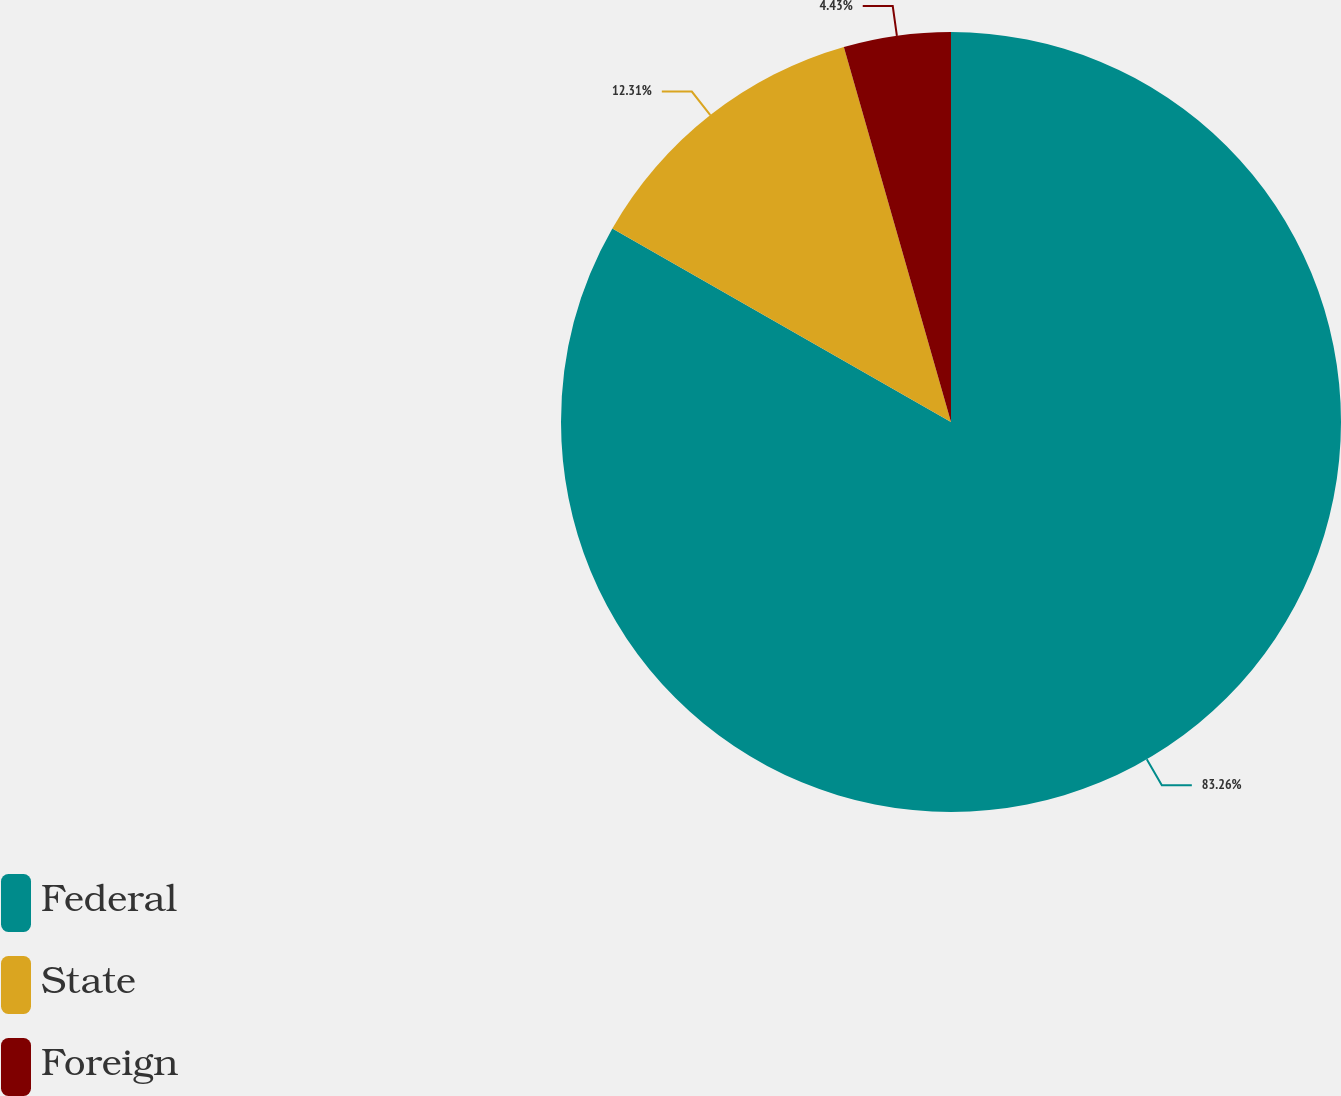Convert chart. <chart><loc_0><loc_0><loc_500><loc_500><pie_chart><fcel>Federal<fcel>State<fcel>Foreign<nl><fcel>83.26%<fcel>12.31%<fcel>4.43%<nl></chart> 